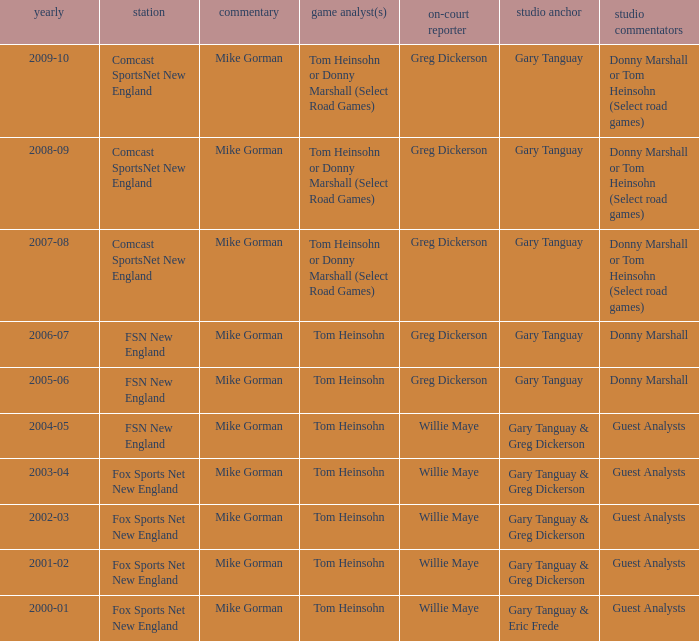WHich Studio host has a Year of 2003-04? Gary Tanguay & Greg Dickerson. 